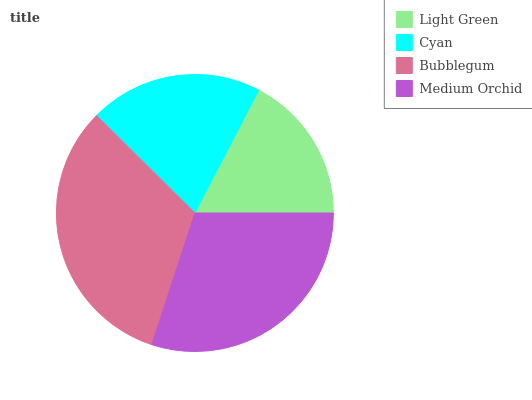Is Light Green the minimum?
Answer yes or no. Yes. Is Bubblegum the maximum?
Answer yes or no. Yes. Is Cyan the minimum?
Answer yes or no. No. Is Cyan the maximum?
Answer yes or no. No. Is Cyan greater than Light Green?
Answer yes or no. Yes. Is Light Green less than Cyan?
Answer yes or no. Yes. Is Light Green greater than Cyan?
Answer yes or no. No. Is Cyan less than Light Green?
Answer yes or no. No. Is Medium Orchid the high median?
Answer yes or no. Yes. Is Cyan the low median?
Answer yes or no. Yes. Is Cyan the high median?
Answer yes or no. No. Is Medium Orchid the low median?
Answer yes or no. No. 